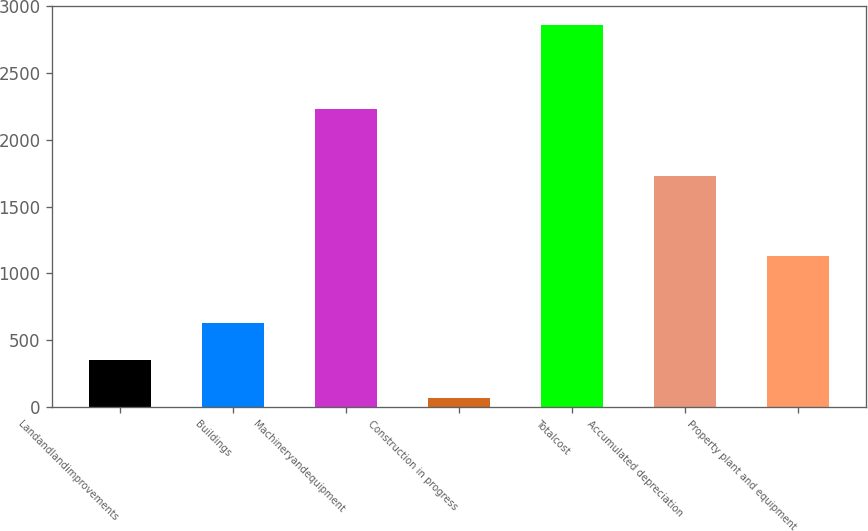Convert chart to OTSL. <chart><loc_0><loc_0><loc_500><loc_500><bar_chart><fcel>Landandlandimprovements<fcel>Buildings<fcel>Machineryandequipment<fcel>Construction in progress<fcel>Totalcost<fcel>Accumulated depreciation<fcel>Property plant and equipment<nl><fcel>348.89<fcel>627.88<fcel>2232.7<fcel>69.9<fcel>2859.8<fcel>1731.7<fcel>1128.1<nl></chart> 